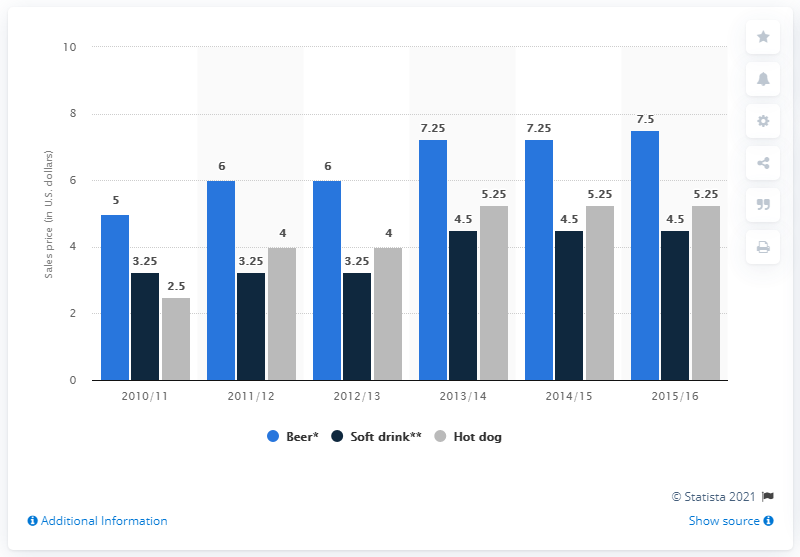Give some essential details in this illustration. In 2013, the difference in beer between 2012 was 1.25. The tallest light blue bar is different from the tallest dark blue bar by 3.. 